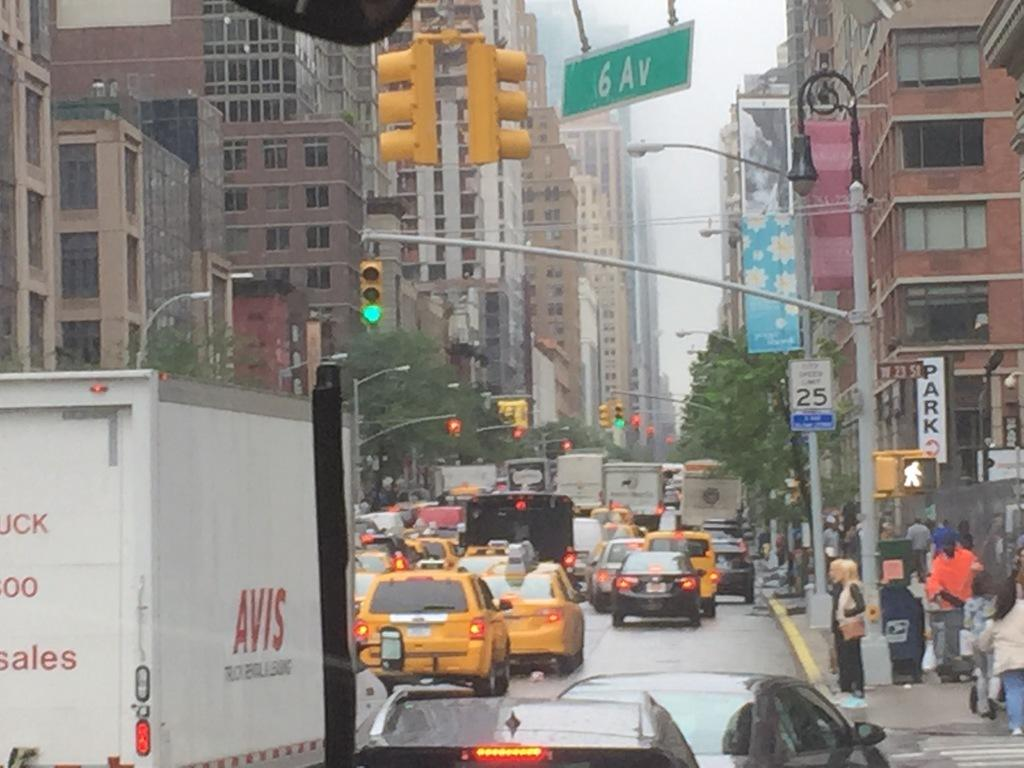Provide a one-sentence caption for the provided image. Traffic is backed up at the intersection of West 23rd and 6th Ave. 